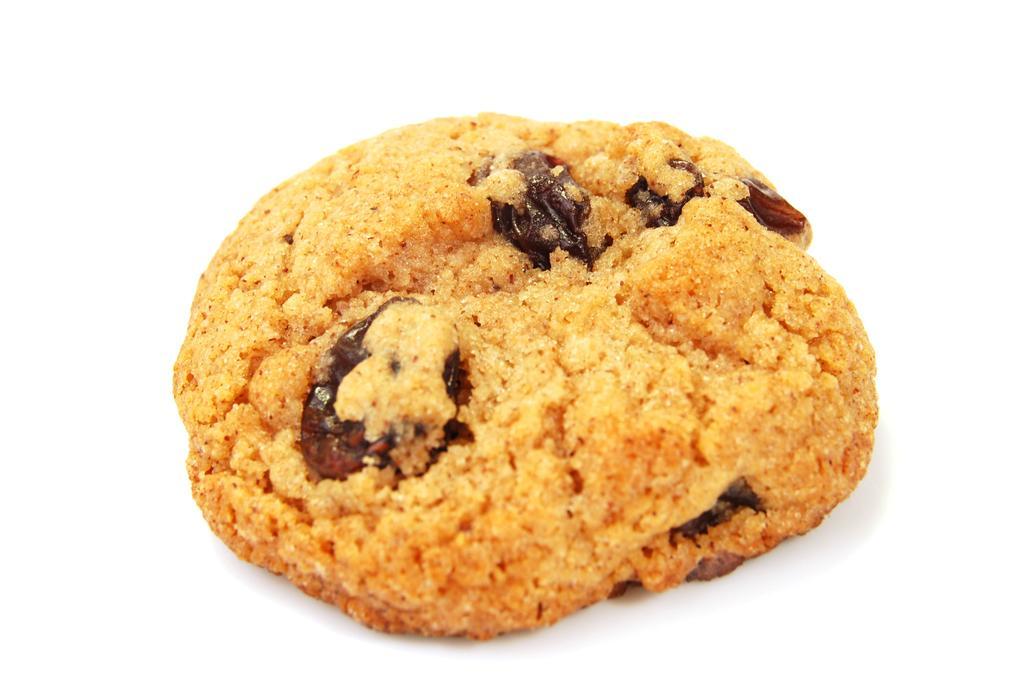Could you give a brief overview of what you see in this image? In this image I can see cookie and there is a white background. 